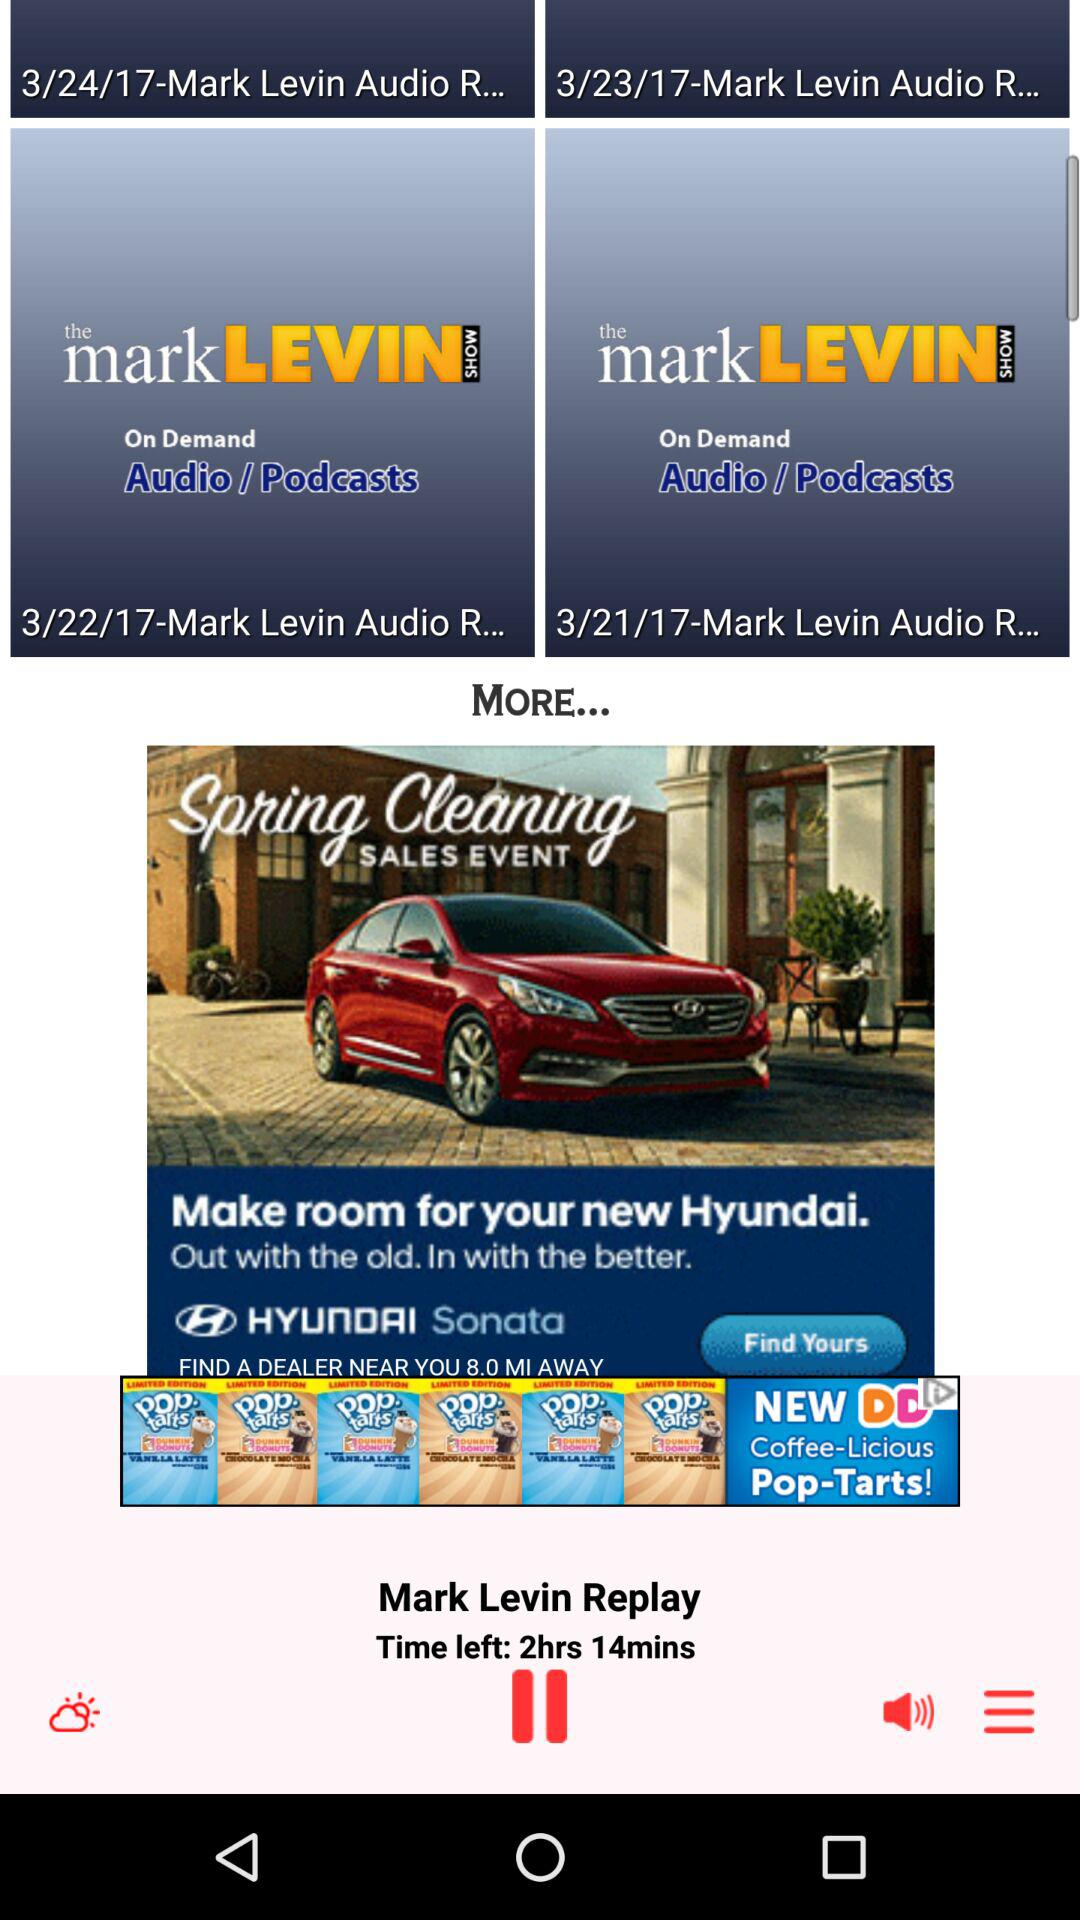What is the podcast name? The podcast name is "The Mark Levin Show". 